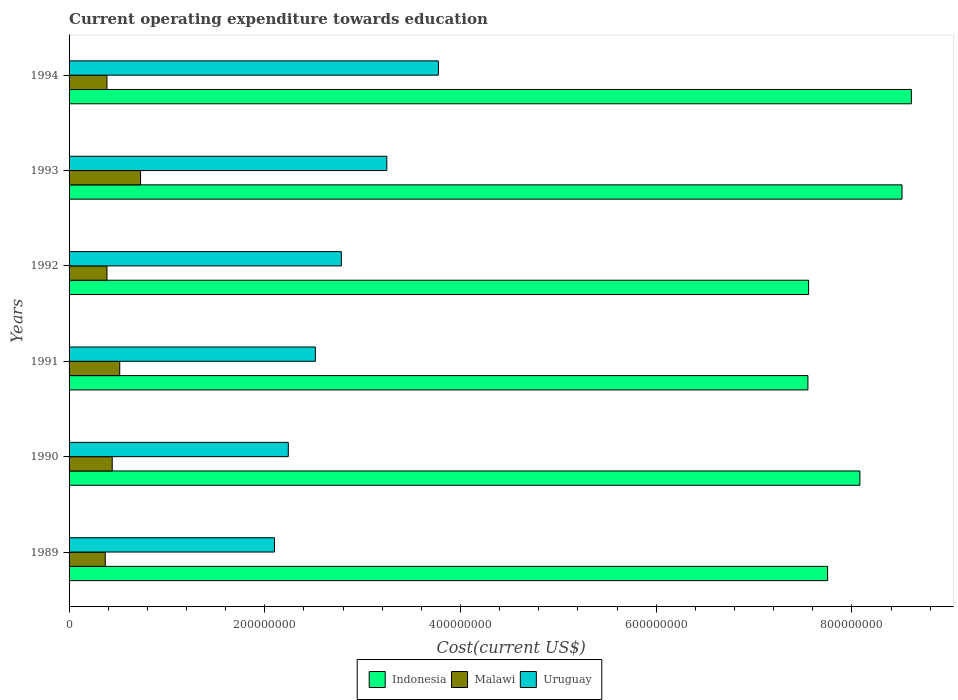How many different coloured bars are there?
Offer a terse response. 3. Are the number of bars per tick equal to the number of legend labels?
Provide a short and direct response. Yes. Are the number of bars on each tick of the Y-axis equal?
Ensure brevity in your answer.  Yes. What is the label of the 4th group of bars from the top?
Provide a succinct answer. 1991. What is the expenditure towards education in Uruguay in 1990?
Offer a terse response. 2.24e+08. Across all years, what is the maximum expenditure towards education in Malawi?
Your answer should be compact. 7.30e+07. Across all years, what is the minimum expenditure towards education in Uruguay?
Provide a short and direct response. 2.10e+08. In which year was the expenditure towards education in Malawi maximum?
Give a very brief answer. 1993. What is the total expenditure towards education in Uruguay in the graph?
Offer a terse response. 1.67e+09. What is the difference between the expenditure towards education in Uruguay in 1991 and that in 1992?
Your response must be concise. -2.65e+07. What is the difference between the expenditure towards education in Malawi in 1994 and the expenditure towards education in Uruguay in 1991?
Offer a very short reply. -2.13e+08. What is the average expenditure towards education in Uruguay per year?
Your response must be concise. 2.78e+08. In the year 1992, what is the difference between the expenditure towards education in Malawi and expenditure towards education in Indonesia?
Your response must be concise. -7.17e+08. In how many years, is the expenditure towards education in Malawi greater than 200000000 US$?
Your answer should be compact. 0. What is the ratio of the expenditure towards education in Uruguay in 1991 to that in 1992?
Ensure brevity in your answer.  0.9. Is the expenditure towards education in Malawi in 1989 less than that in 1990?
Your answer should be compact. Yes. What is the difference between the highest and the second highest expenditure towards education in Malawi?
Provide a succinct answer. 2.13e+07. What is the difference between the highest and the lowest expenditure towards education in Uruguay?
Provide a succinct answer. 1.68e+08. In how many years, is the expenditure towards education in Indonesia greater than the average expenditure towards education in Indonesia taken over all years?
Make the answer very short. 3. Is the sum of the expenditure towards education in Indonesia in 1990 and 1993 greater than the maximum expenditure towards education in Uruguay across all years?
Offer a terse response. Yes. What does the 3rd bar from the top in 1991 represents?
Offer a terse response. Indonesia. What does the 1st bar from the bottom in 1992 represents?
Keep it short and to the point. Indonesia. How many bars are there?
Offer a very short reply. 18. What is the difference between two consecutive major ticks on the X-axis?
Provide a succinct answer. 2.00e+08. Where does the legend appear in the graph?
Your response must be concise. Bottom center. How many legend labels are there?
Offer a very short reply. 3. What is the title of the graph?
Offer a terse response. Current operating expenditure towards education. Does "Nigeria" appear as one of the legend labels in the graph?
Your answer should be compact. No. What is the label or title of the X-axis?
Offer a very short reply. Cost(current US$). What is the Cost(current US$) of Indonesia in 1989?
Make the answer very short. 7.75e+08. What is the Cost(current US$) of Malawi in 1989?
Your response must be concise. 3.70e+07. What is the Cost(current US$) in Uruguay in 1989?
Make the answer very short. 2.10e+08. What is the Cost(current US$) in Indonesia in 1990?
Ensure brevity in your answer.  8.08e+08. What is the Cost(current US$) of Malawi in 1990?
Your answer should be compact. 4.41e+07. What is the Cost(current US$) in Uruguay in 1990?
Ensure brevity in your answer.  2.24e+08. What is the Cost(current US$) of Indonesia in 1991?
Your answer should be very brief. 7.55e+08. What is the Cost(current US$) of Malawi in 1991?
Give a very brief answer. 5.18e+07. What is the Cost(current US$) of Uruguay in 1991?
Offer a terse response. 2.52e+08. What is the Cost(current US$) of Indonesia in 1992?
Keep it short and to the point. 7.56e+08. What is the Cost(current US$) of Malawi in 1992?
Offer a terse response. 3.87e+07. What is the Cost(current US$) of Uruguay in 1992?
Your answer should be compact. 2.78e+08. What is the Cost(current US$) of Indonesia in 1993?
Provide a succinct answer. 8.51e+08. What is the Cost(current US$) in Malawi in 1993?
Your answer should be very brief. 7.30e+07. What is the Cost(current US$) of Uruguay in 1993?
Give a very brief answer. 3.25e+08. What is the Cost(current US$) of Indonesia in 1994?
Your answer should be very brief. 8.61e+08. What is the Cost(current US$) of Malawi in 1994?
Offer a very short reply. 3.87e+07. What is the Cost(current US$) in Uruguay in 1994?
Your answer should be very brief. 3.77e+08. Across all years, what is the maximum Cost(current US$) in Indonesia?
Provide a succinct answer. 8.61e+08. Across all years, what is the maximum Cost(current US$) of Malawi?
Provide a succinct answer. 7.30e+07. Across all years, what is the maximum Cost(current US$) in Uruguay?
Your response must be concise. 3.77e+08. Across all years, what is the minimum Cost(current US$) in Indonesia?
Offer a very short reply. 7.55e+08. Across all years, what is the minimum Cost(current US$) of Malawi?
Make the answer very short. 3.70e+07. Across all years, what is the minimum Cost(current US$) in Uruguay?
Your answer should be compact. 2.10e+08. What is the total Cost(current US$) in Indonesia in the graph?
Make the answer very short. 4.81e+09. What is the total Cost(current US$) of Malawi in the graph?
Provide a succinct answer. 2.83e+08. What is the total Cost(current US$) of Uruguay in the graph?
Give a very brief answer. 1.67e+09. What is the difference between the Cost(current US$) of Indonesia in 1989 and that in 1990?
Your response must be concise. -3.30e+07. What is the difference between the Cost(current US$) in Malawi in 1989 and that in 1990?
Your answer should be compact. -7.13e+06. What is the difference between the Cost(current US$) in Uruguay in 1989 and that in 1990?
Ensure brevity in your answer.  -1.41e+07. What is the difference between the Cost(current US$) in Indonesia in 1989 and that in 1991?
Provide a short and direct response. 2.01e+07. What is the difference between the Cost(current US$) in Malawi in 1989 and that in 1991?
Provide a succinct answer. -1.48e+07. What is the difference between the Cost(current US$) of Uruguay in 1989 and that in 1991?
Provide a succinct answer. -4.18e+07. What is the difference between the Cost(current US$) of Indonesia in 1989 and that in 1992?
Your answer should be compact. 1.94e+07. What is the difference between the Cost(current US$) of Malawi in 1989 and that in 1992?
Offer a terse response. -1.76e+06. What is the difference between the Cost(current US$) of Uruguay in 1989 and that in 1992?
Provide a succinct answer. -6.84e+07. What is the difference between the Cost(current US$) of Indonesia in 1989 and that in 1993?
Offer a terse response. -7.60e+07. What is the difference between the Cost(current US$) of Malawi in 1989 and that in 1993?
Your answer should be compact. -3.61e+07. What is the difference between the Cost(current US$) of Uruguay in 1989 and that in 1993?
Provide a succinct answer. -1.15e+08. What is the difference between the Cost(current US$) of Indonesia in 1989 and that in 1994?
Your answer should be compact. -8.56e+07. What is the difference between the Cost(current US$) of Malawi in 1989 and that in 1994?
Your answer should be compact. -1.74e+06. What is the difference between the Cost(current US$) in Uruguay in 1989 and that in 1994?
Keep it short and to the point. -1.68e+08. What is the difference between the Cost(current US$) in Indonesia in 1990 and that in 1991?
Offer a very short reply. 5.31e+07. What is the difference between the Cost(current US$) in Malawi in 1990 and that in 1991?
Provide a short and direct response. -7.67e+06. What is the difference between the Cost(current US$) in Uruguay in 1990 and that in 1991?
Offer a very short reply. -2.77e+07. What is the difference between the Cost(current US$) of Indonesia in 1990 and that in 1992?
Give a very brief answer. 5.24e+07. What is the difference between the Cost(current US$) in Malawi in 1990 and that in 1992?
Your response must be concise. 5.37e+06. What is the difference between the Cost(current US$) in Uruguay in 1990 and that in 1992?
Provide a succinct answer. -5.42e+07. What is the difference between the Cost(current US$) of Indonesia in 1990 and that in 1993?
Your response must be concise. -4.30e+07. What is the difference between the Cost(current US$) of Malawi in 1990 and that in 1993?
Your response must be concise. -2.89e+07. What is the difference between the Cost(current US$) of Uruguay in 1990 and that in 1993?
Provide a succinct answer. -1.01e+08. What is the difference between the Cost(current US$) in Indonesia in 1990 and that in 1994?
Ensure brevity in your answer.  -5.26e+07. What is the difference between the Cost(current US$) in Malawi in 1990 and that in 1994?
Your answer should be compact. 5.39e+06. What is the difference between the Cost(current US$) of Uruguay in 1990 and that in 1994?
Provide a succinct answer. -1.53e+08. What is the difference between the Cost(current US$) of Indonesia in 1991 and that in 1992?
Make the answer very short. -7.18e+05. What is the difference between the Cost(current US$) in Malawi in 1991 and that in 1992?
Offer a very short reply. 1.30e+07. What is the difference between the Cost(current US$) of Uruguay in 1991 and that in 1992?
Your answer should be compact. -2.65e+07. What is the difference between the Cost(current US$) of Indonesia in 1991 and that in 1993?
Make the answer very short. -9.61e+07. What is the difference between the Cost(current US$) in Malawi in 1991 and that in 1993?
Provide a succinct answer. -2.13e+07. What is the difference between the Cost(current US$) of Uruguay in 1991 and that in 1993?
Offer a terse response. -7.30e+07. What is the difference between the Cost(current US$) in Indonesia in 1991 and that in 1994?
Your answer should be very brief. -1.06e+08. What is the difference between the Cost(current US$) in Malawi in 1991 and that in 1994?
Offer a terse response. 1.31e+07. What is the difference between the Cost(current US$) in Uruguay in 1991 and that in 1994?
Make the answer very short. -1.26e+08. What is the difference between the Cost(current US$) of Indonesia in 1992 and that in 1993?
Provide a succinct answer. -9.54e+07. What is the difference between the Cost(current US$) in Malawi in 1992 and that in 1993?
Make the answer very short. -3.43e+07. What is the difference between the Cost(current US$) of Uruguay in 1992 and that in 1993?
Ensure brevity in your answer.  -4.65e+07. What is the difference between the Cost(current US$) of Indonesia in 1992 and that in 1994?
Offer a very short reply. -1.05e+08. What is the difference between the Cost(current US$) of Malawi in 1992 and that in 1994?
Give a very brief answer. 1.95e+04. What is the difference between the Cost(current US$) of Uruguay in 1992 and that in 1994?
Offer a very short reply. -9.92e+07. What is the difference between the Cost(current US$) of Indonesia in 1993 and that in 1994?
Ensure brevity in your answer.  -9.59e+06. What is the difference between the Cost(current US$) in Malawi in 1993 and that in 1994?
Keep it short and to the point. 3.43e+07. What is the difference between the Cost(current US$) in Uruguay in 1993 and that in 1994?
Provide a succinct answer. -5.27e+07. What is the difference between the Cost(current US$) of Indonesia in 1989 and the Cost(current US$) of Malawi in 1990?
Your response must be concise. 7.31e+08. What is the difference between the Cost(current US$) in Indonesia in 1989 and the Cost(current US$) in Uruguay in 1990?
Ensure brevity in your answer.  5.51e+08. What is the difference between the Cost(current US$) of Malawi in 1989 and the Cost(current US$) of Uruguay in 1990?
Make the answer very short. -1.87e+08. What is the difference between the Cost(current US$) in Indonesia in 1989 and the Cost(current US$) in Malawi in 1991?
Make the answer very short. 7.23e+08. What is the difference between the Cost(current US$) of Indonesia in 1989 and the Cost(current US$) of Uruguay in 1991?
Make the answer very short. 5.23e+08. What is the difference between the Cost(current US$) of Malawi in 1989 and the Cost(current US$) of Uruguay in 1991?
Offer a terse response. -2.15e+08. What is the difference between the Cost(current US$) of Indonesia in 1989 and the Cost(current US$) of Malawi in 1992?
Your response must be concise. 7.36e+08. What is the difference between the Cost(current US$) of Indonesia in 1989 and the Cost(current US$) of Uruguay in 1992?
Make the answer very short. 4.97e+08. What is the difference between the Cost(current US$) in Malawi in 1989 and the Cost(current US$) in Uruguay in 1992?
Your response must be concise. -2.41e+08. What is the difference between the Cost(current US$) in Indonesia in 1989 and the Cost(current US$) in Malawi in 1993?
Your answer should be compact. 7.02e+08. What is the difference between the Cost(current US$) of Indonesia in 1989 and the Cost(current US$) of Uruguay in 1993?
Your answer should be very brief. 4.50e+08. What is the difference between the Cost(current US$) in Malawi in 1989 and the Cost(current US$) in Uruguay in 1993?
Your answer should be compact. -2.88e+08. What is the difference between the Cost(current US$) in Indonesia in 1989 and the Cost(current US$) in Malawi in 1994?
Your answer should be very brief. 7.36e+08. What is the difference between the Cost(current US$) of Indonesia in 1989 and the Cost(current US$) of Uruguay in 1994?
Offer a terse response. 3.98e+08. What is the difference between the Cost(current US$) of Malawi in 1989 and the Cost(current US$) of Uruguay in 1994?
Offer a very short reply. -3.40e+08. What is the difference between the Cost(current US$) in Indonesia in 1990 and the Cost(current US$) in Malawi in 1991?
Provide a short and direct response. 7.56e+08. What is the difference between the Cost(current US$) in Indonesia in 1990 and the Cost(current US$) in Uruguay in 1991?
Your answer should be compact. 5.56e+08. What is the difference between the Cost(current US$) in Malawi in 1990 and the Cost(current US$) in Uruguay in 1991?
Give a very brief answer. -2.08e+08. What is the difference between the Cost(current US$) in Indonesia in 1990 and the Cost(current US$) in Malawi in 1992?
Give a very brief answer. 7.69e+08. What is the difference between the Cost(current US$) in Indonesia in 1990 and the Cost(current US$) in Uruguay in 1992?
Provide a short and direct response. 5.30e+08. What is the difference between the Cost(current US$) in Malawi in 1990 and the Cost(current US$) in Uruguay in 1992?
Your answer should be very brief. -2.34e+08. What is the difference between the Cost(current US$) in Indonesia in 1990 and the Cost(current US$) in Malawi in 1993?
Your response must be concise. 7.35e+08. What is the difference between the Cost(current US$) in Indonesia in 1990 and the Cost(current US$) in Uruguay in 1993?
Your response must be concise. 4.83e+08. What is the difference between the Cost(current US$) of Malawi in 1990 and the Cost(current US$) of Uruguay in 1993?
Keep it short and to the point. -2.81e+08. What is the difference between the Cost(current US$) of Indonesia in 1990 and the Cost(current US$) of Malawi in 1994?
Keep it short and to the point. 7.69e+08. What is the difference between the Cost(current US$) in Indonesia in 1990 and the Cost(current US$) in Uruguay in 1994?
Give a very brief answer. 4.31e+08. What is the difference between the Cost(current US$) of Malawi in 1990 and the Cost(current US$) of Uruguay in 1994?
Offer a very short reply. -3.33e+08. What is the difference between the Cost(current US$) of Indonesia in 1991 and the Cost(current US$) of Malawi in 1992?
Offer a terse response. 7.16e+08. What is the difference between the Cost(current US$) in Indonesia in 1991 and the Cost(current US$) in Uruguay in 1992?
Your response must be concise. 4.77e+08. What is the difference between the Cost(current US$) in Malawi in 1991 and the Cost(current US$) in Uruguay in 1992?
Make the answer very short. -2.26e+08. What is the difference between the Cost(current US$) in Indonesia in 1991 and the Cost(current US$) in Malawi in 1993?
Provide a succinct answer. 6.82e+08. What is the difference between the Cost(current US$) of Indonesia in 1991 and the Cost(current US$) of Uruguay in 1993?
Ensure brevity in your answer.  4.30e+08. What is the difference between the Cost(current US$) in Malawi in 1991 and the Cost(current US$) in Uruguay in 1993?
Give a very brief answer. -2.73e+08. What is the difference between the Cost(current US$) in Indonesia in 1991 and the Cost(current US$) in Malawi in 1994?
Offer a terse response. 7.16e+08. What is the difference between the Cost(current US$) in Indonesia in 1991 and the Cost(current US$) in Uruguay in 1994?
Your response must be concise. 3.78e+08. What is the difference between the Cost(current US$) of Malawi in 1991 and the Cost(current US$) of Uruguay in 1994?
Your response must be concise. -3.26e+08. What is the difference between the Cost(current US$) in Indonesia in 1992 and the Cost(current US$) in Malawi in 1993?
Keep it short and to the point. 6.83e+08. What is the difference between the Cost(current US$) in Indonesia in 1992 and the Cost(current US$) in Uruguay in 1993?
Offer a terse response. 4.31e+08. What is the difference between the Cost(current US$) in Malawi in 1992 and the Cost(current US$) in Uruguay in 1993?
Offer a very short reply. -2.86e+08. What is the difference between the Cost(current US$) of Indonesia in 1992 and the Cost(current US$) of Malawi in 1994?
Your answer should be very brief. 7.17e+08. What is the difference between the Cost(current US$) in Indonesia in 1992 and the Cost(current US$) in Uruguay in 1994?
Offer a very short reply. 3.78e+08. What is the difference between the Cost(current US$) in Malawi in 1992 and the Cost(current US$) in Uruguay in 1994?
Keep it short and to the point. -3.39e+08. What is the difference between the Cost(current US$) in Indonesia in 1993 and the Cost(current US$) in Malawi in 1994?
Make the answer very short. 8.12e+08. What is the difference between the Cost(current US$) in Indonesia in 1993 and the Cost(current US$) in Uruguay in 1994?
Your response must be concise. 4.74e+08. What is the difference between the Cost(current US$) of Malawi in 1993 and the Cost(current US$) of Uruguay in 1994?
Your response must be concise. -3.04e+08. What is the average Cost(current US$) of Indonesia per year?
Offer a terse response. 8.01e+08. What is the average Cost(current US$) in Malawi per year?
Ensure brevity in your answer.  4.72e+07. What is the average Cost(current US$) in Uruguay per year?
Your answer should be very brief. 2.78e+08. In the year 1989, what is the difference between the Cost(current US$) of Indonesia and Cost(current US$) of Malawi?
Ensure brevity in your answer.  7.38e+08. In the year 1989, what is the difference between the Cost(current US$) of Indonesia and Cost(current US$) of Uruguay?
Your answer should be very brief. 5.65e+08. In the year 1989, what is the difference between the Cost(current US$) in Malawi and Cost(current US$) in Uruguay?
Give a very brief answer. -1.73e+08. In the year 1990, what is the difference between the Cost(current US$) of Indonesia and Cost(current US$) of Malawi?
Offer a terse response. 7.64e+08. In the year 1990, what is the difference between the Cost(current US$) in Indonesia and Cost(current US$) in Uruguay?
Your response must be concise. 5.84e+08. In the year 1990, what is the difference between the Cost(current US$) in Malawi and Cost(current US$) in Uruguay?
Provide a short and direct response. -1.80e+08. In the year 1991, what is the difference between the Cost(current US$) of Indonesia and Cost(current US$) of Malawi?
Ensure brevity in your answer.  7.03e+08. In the year 1991, what is the difference between the Cost(current US$) of Indonesia and Cost(current US$) of Uruguay?
Provide a short and direct response. 5.03e+08. In the year 1991, what is the difference between the Cost(current US$) of Malawi and Cost(current US$) of Uruguay?
Make the answer very short. -2.00e+08. In the year 1992, what is the difference between the Cost(current US$) of Indonesia and Cost(current US$) of Malawi?
Keep it short and to the point. 7.17e+08. In the year 1992, what is the difference between the Cost(current US$) in Indonesia and Cost(current US$) in Uruguay?
Offer a terse response. 4.78e+08. In the year 1992, what is the difference between the Cost(current US$) of Malawi and Cost(current US$) of Uruguay?
Ensure brevity in your answer.  -2.39e+08. In the year 1993, what is the difference between the Cost(current US$) in Indonesia and Cost(current US$) in Malawi?
Provide a short and direct response. 7.78e+08. In the year 1993, what is the difference between the Cost(current US$) of Indonesia and Cost(current US$) of Uruguay?
Make the answer very short. 5.26e+08. In the year 1993, what is the difference between the Cost(current US$) of Malawi and Cost(current US$) of Uruguay?
Make the answer very short. -2.52e+08. In the year 1994, what is the difference between the Cost(current US$) in Indonesia and Cost(current US$) in Malawi?
Your answer should be compact. 8.22e+08. In the year 1994, what is the difference between the Cost(current US$) in Indonesia and Cost(current US$) in Uruguay?
Give a very brief answer. 4.83e+08. In the year 1994, what is the difference between the Cost(current US$) of Malawi and Cost(current US$) of Uruguay?
Give a very brief answer. -3.39e+08. What is the ratio of the Cost(current US$) of Indonesia in 1989 to that in 1990?
Provide a short and direct response. 0.96. What is the ratio of the Cost(current US$) of Malawi in 1989 to that in 1990?
Give a very brief answer. 0.84. What is the ratio of the Cost(current US$) of Uruguay in 1989 to that in 1990?
Offer a very short reply. 0.94. What is the ratio of the Cost(current US$) in Indonesia in 1989 to that in 1991?
Your answer should be compact. 1.03. What is the ratio of the Cost(current US$) of Malawi in 1989 to that in 1991?
Make the answer very short. 0.71. What is the ratio of the Cost(current US$) of Uruguay in 1989 to that in 1991?
Provide a short and direct response. 0.83. What is the ratio of the Cost(current US$) of Indonesia in 1989 to that in 1992?
Provide a short and direct response. 1.03. What is the ratio of the Cost(current US$) in Malawi in 1989 to that in 1992?
Offer a terse response. 0.95. What is the ratio of the Cost(current US$) in Uruguay in 1989 to that in 1992?
Your answer should be compact. 0.75. What is the ratio of the Cost(current US$) of Indonesia in 1989 to that in 1993?
Keep it short and to the point. 0.91. What is the ratio of the Cost(current US$) in Malawi in 1989 to that in 1993?
Provide a succinct answer. 0.51. What is the ratio of the Cost(current US$) in Uruguay in 1989 to that in 1993?
Give a very brief answer. 0.65. What is the ratio of the Cost(current US$) in Indonesia in 1989 to that in 1994?
Make the answer very short. 0.9. What is the ratio of the Cost(current US$) of Malawi in 1989 to that in 1994?
Your response must be concise. 0.95. What is the ratio of the Cost(current US$) of Uruguay in 1989 to that in 1994?
Keep it short and to the point. 0.56. What is the ratio of the Cost(current US$) in Indonesia in 1990 to that in 1991?
Your answer should be compact. 1.07. What is the ratio of the Cost(current US$) in Malawi in 1990 to that in 1991?
Keep it short and to the point. 0.85. What is the ratio of the Cost(current US$) in Uruguay in 1990 to that in 1991?
Ensure brevity in your answer.  0.89. What is the ratio of the Cost(current US$) in Indonesia in 1990 to that in 1992?
Offer a terse response. 1.07. What is the ratio of the Cost(current US$) in Malawi in 1990 to that in 1992?
Your response must be concise. 1.14. What is the ratio of the Cost(current US$) in Uruguay in 1990 to that in 1992?
Provide a short and direct response. 0.81. What is the ratio of the Cost(current US$) in Indonesia in 1990 to that in 1993?
Keep it short and to the point. 0.95. What is the ratio of the Cost(current US$) of Malawi in 1990 to that in 1993?
Keep it short and to the point. 0.6. What is the ratio of the Cost(current US$) in Uruguay in 1990 to that in 1993?
Offer a terse response. 0.69. What is the ratio of the Cost(current US$) of Indonesia in 1990 to that in 1994?
Offer a terse response. 0.94. What is the ratio of the Cost(current US$) in Malawi in 1990 to that in 1994?
Ensure brevity in your answer.  1.14. What is the ratio of the Cost(current US$) in Uruguay in 1990 to that in 1994?
Make the answer very short. 0.59. What is the ratio of the Cost(current US$) of Malawi in 1991 to that in 1992?
Offer a terse response. 1.34. What is the ratio of the Cost(current US$) in Uruguay in 1991 to that in 1992?
Offer a very short reply. 0.9. What is the ratio of the Cost(current US$) in Indonesia in 1991 to that in 1993?
Keep it short and to the point. 0.89. What is the ratio of the Cost(current US$) in Malawi in 1991 to that in 1993?
Provide a short and direct response. 0.71. What is the ratio of the Cost(current US$) in Uruguay in 1991 to that in 1993?
Make the answer very short. 0.78. What is the ratio of the Cost(current US$) of Indonesia in 1991 to that in 1994?
Make the answer very short. 0.88. What is the ratio of the Cost(current US$) in Malawi in 1991 to that in 1994?
Provide a short and direct response. 1.34. What is the ratio of the Cost(current US$) of Uruguay in 1991 to that in 1994?
Your answer should be very brief. 0.67. What is the ratio of the Cost(current US$) of Indonesia in 1992 to that in 1993?
Provide a succinct answer. 0.89. What is the ratio of the Cost(current US$) in Malawi in 1992 to that in 1993?
Make the answer very short. 0.53. What is the ratio of the Cost(current US$) in Uruguay in 1992 to that in 1993?
Provide a short and direct response. 0.86. What is the ratio of the Cost(current US$) of Indonesia in 1992 to that in 1994?
Keep it short and to the point. 0.88. What is the ratio of the Cost(current US$) in Uruguay in 1992 to that in 1994?
Offer a terse response. 0.74. What is the ratio of the Cost(current US$) of Indonesia in 1993 to that in 1994?
Give a very brief answer. 0.99. What is the ratio of the Cost(current US$) of Malawi in 1993 to that in 1994?
Provide a short and direct response. 1.89. What is the ratio of the Cost(current US$) in Uruguay in 1993 to that in 1994?
Offer a terse response. 0.86. What is the difference between the highest and the second highest Cost(current US$) of Indonesia?
Provide a short and direct response. 9.59e+06. What is the difference between the highest and the second highest Cost(current US$) in Malawi?
Your answer should be very brief. 2.13e+07. What is the difference between the highest and the second highest Cost(current US$) of Uruguay?
Make the answer very short. 5.27e+07. What is the difference between the highest and the lowest Cost(current US$) in Indonesia?
Make the answer very short. 1.06e+08. What is the difference between the highest and the lowest Cost(current US$) of Malawi?
Make the answer very short. 3.61e+07. What is the difference between the highest and the lowest Cost(current US$) in Uruguay?
Your answer should be very brief. 1.68e+08. 